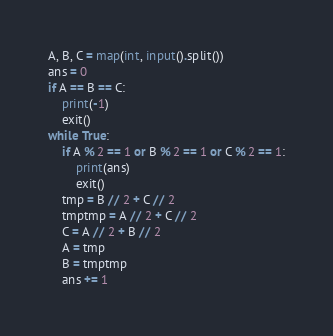Convert code to text. <code><loc_0><loc_0><loc_500><loc_500><_Python_>A, B, C = map(int, input().split())
ans = 0
if A == B == C:
    print(-1)
    exit()
while True:
    if A % 2 == 1 or B % 2 == 1 or C % 2 == 1:
        print(ans)
        exit()
    tmp = B // 2 + C // 2
    tmptmp = A // 2 + C // 2
    C = A // 2 + B // 2
    A = tmp
    B = tmptmp
    ans += 1



</code> 